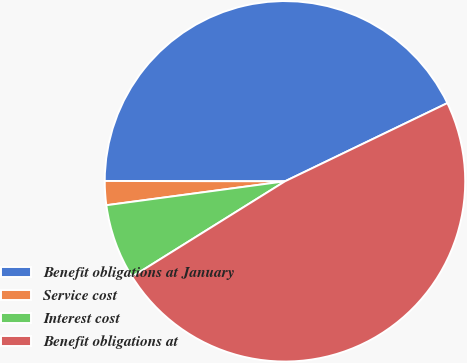Convert chart to OTSL. <chart><loc_0><loc_0><loc_500><loc_500><pie_chart><fcel>Benefit obligations at January<fcel>Service cost<fcel>Interest cost<fcel>Benefit obligations at<nl><fcel>42.82%<fcel>2.15%<fcel>6.76%<fcel>48.26%<nl></chart> 